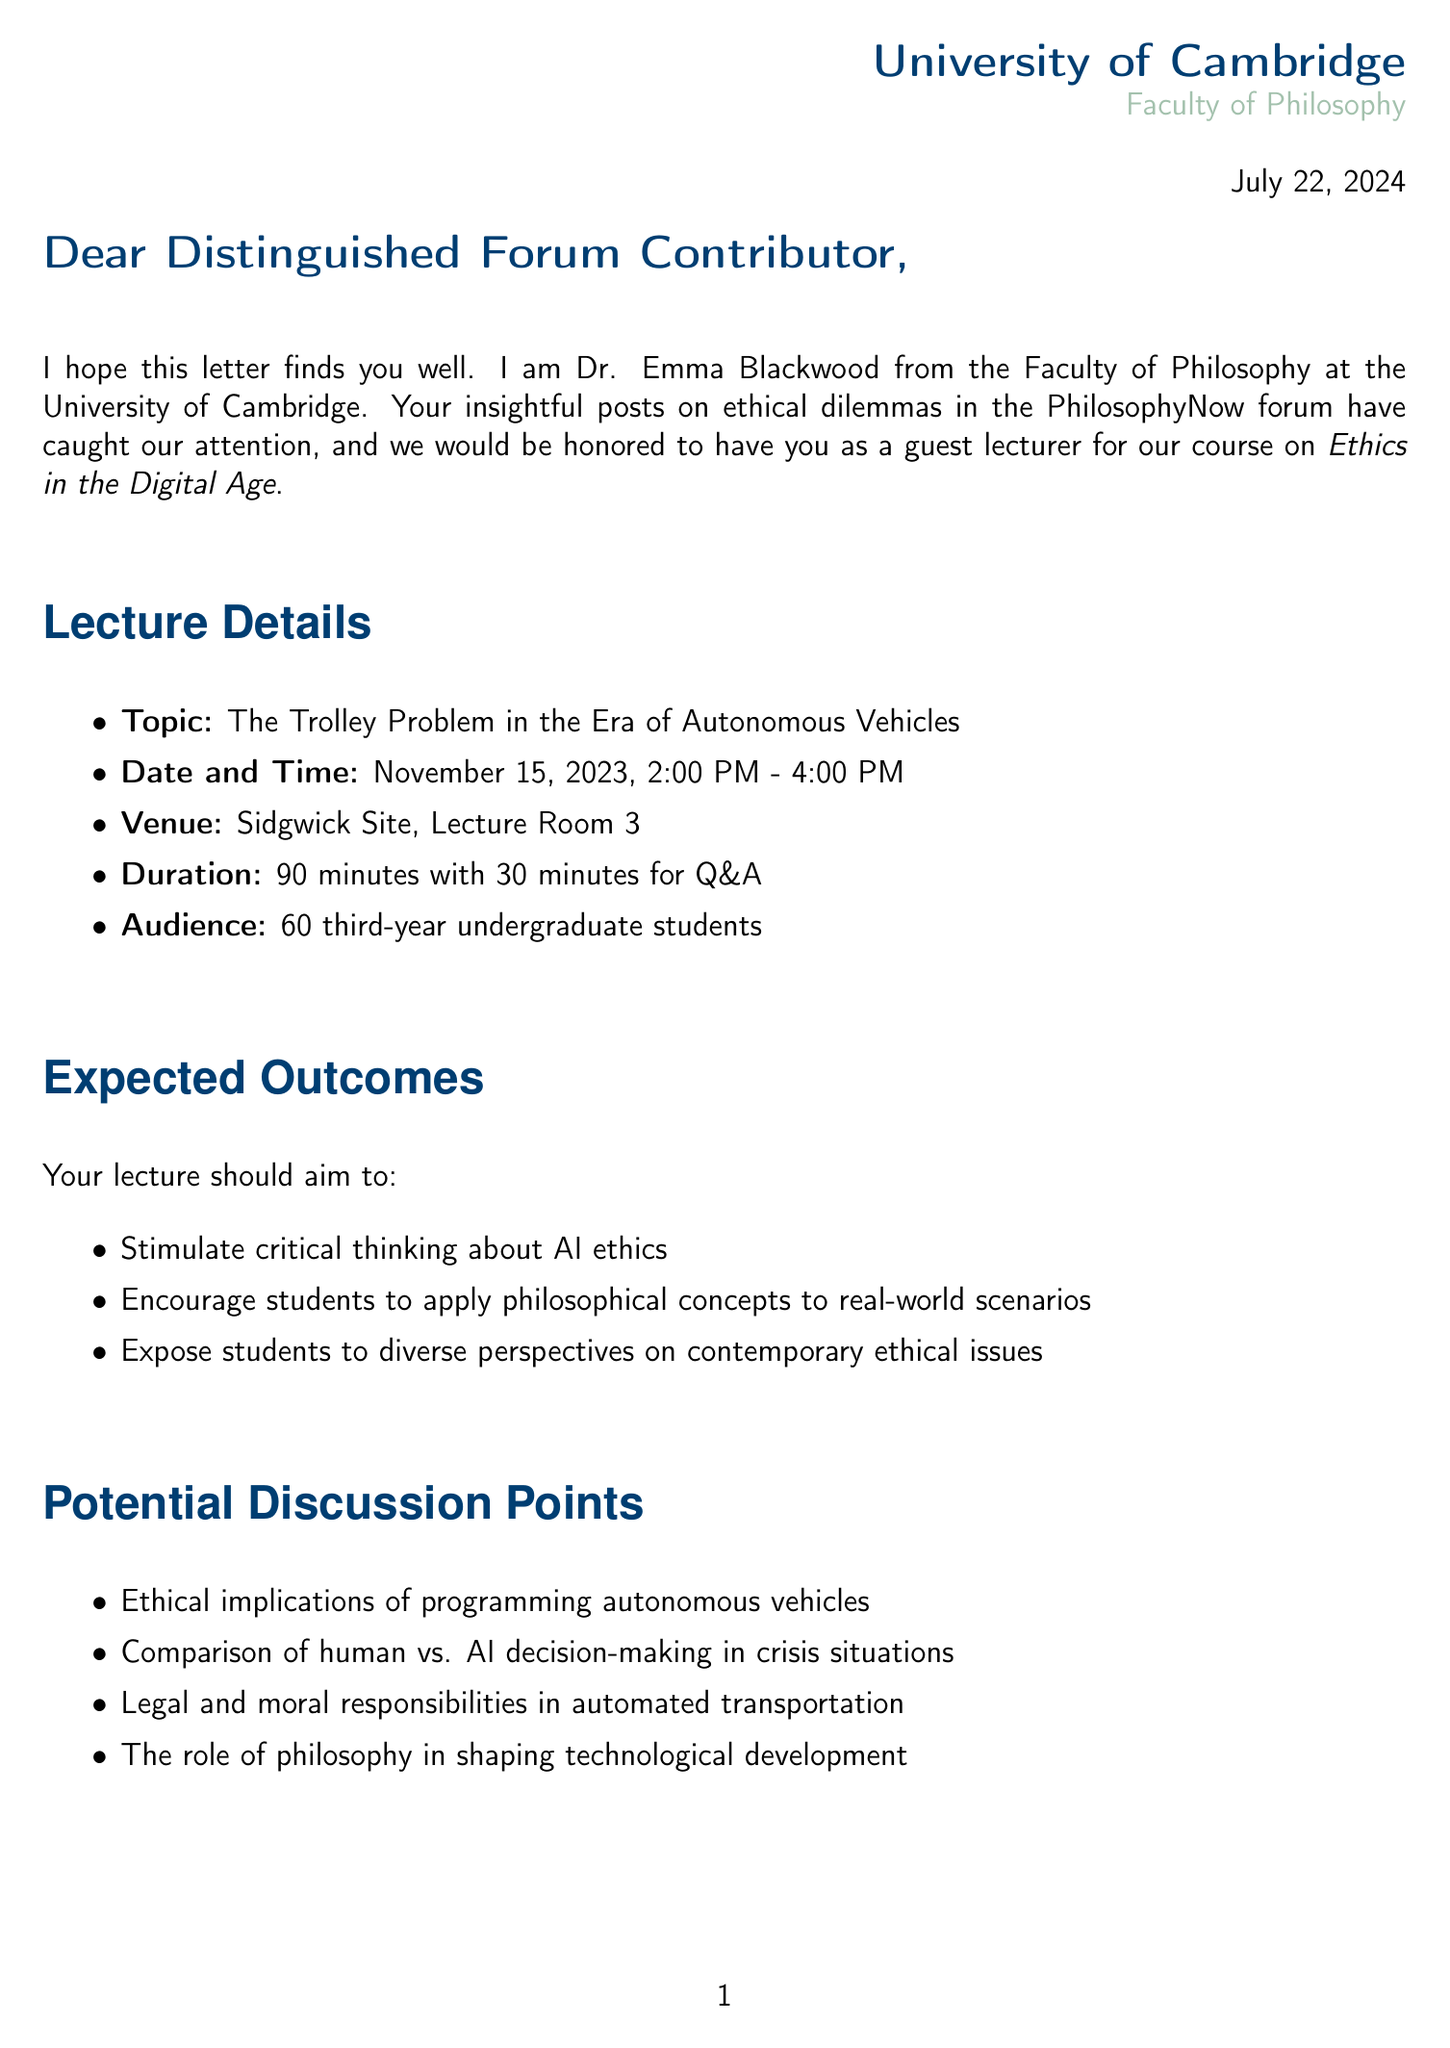What is the name of the course? The course name is mentioned in the letter as part of the invitation, which is "Ethics in the Digital Age."
Answer: Ethics in the Digital Age Who is the lecturer sending the invitation? The letter specifies the lecturer's name as Dr. Emma Blackwood, who is from the Faculty of Philosophy.
Answer: Dr. Emma Blackwood What is the date and time of the guest lecture? The letter provides the specific date and time: November 15, 2023, from 2:00 PM to 4:00 PM.
Answer: November 15, 2023, 2:00 PM - 4:00 PM How long is the Q&A session scheduled for? The document explicitly states that the Q&A session will last for 30 minutes following the 90-minute lecture.
Answer: 30 minutes What is the honorarium offered for the guest lecture? The honorarium figure is stated within the practical arrangements as £500.
Answer: £500 What is one expected outcome of the lecture? The letter lists several expected outcomes, asking the lecturer to stimulate critical thinking about AI ethics.
Answer: Stimulate critical thinking about AI ethics What will be provided for travel arrangements? The travel arrangements detailed in the letter mention reimbursement for standard class train fare.
Answer: Reimbursement for standard class train fare What kind of materials are required for the lecture? The letter requests the preparation of specific materials: a PowerPoint presentation and handouts for the students.
Answer: PowerPoint presentation and handouts Who should the lecturer contact for questions? The contact person for inquiries is specified as Ms. Olivia Chen, with an email provided for communication.
Answer: Ms. Olivia Chen, oc267@cam.ac.uk 